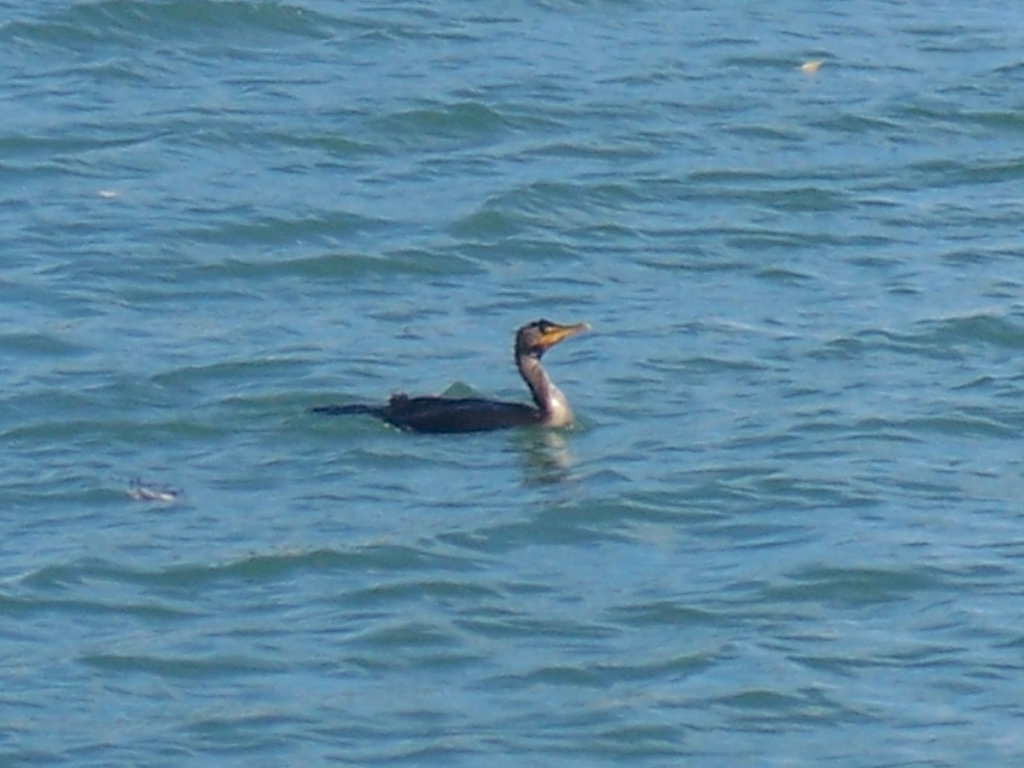This body of water looks calm; is it typical for cormorants to be in such environments? Yes, cormorants can often be found in calm bodies of water, which may make it easier for them to hunt for fish. They do not restrict themselves exclusively to calm water, but it is quite common to observe them in such settings. How do they catch their food? Cormorants are skilled divers and catch their prey underwater. They propel themselves with webbed feet and navigate with great agility to capture fish or other aquatic animals with their sharp, hooked bills. 